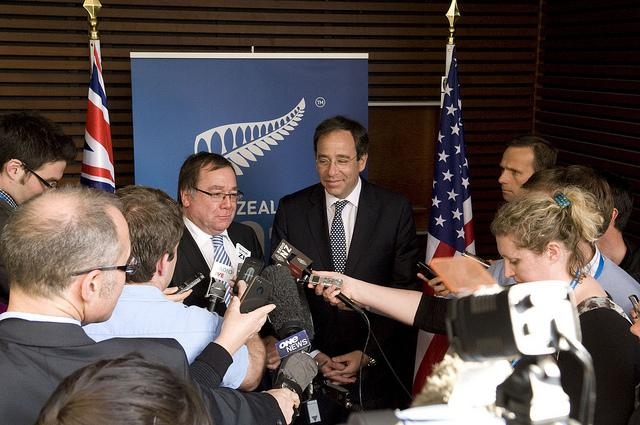What does the NZ on the microphone stand for?

Choices:
A) neutral zone
B) national-zeitung
C) net zero
D) new zealand new zealand 